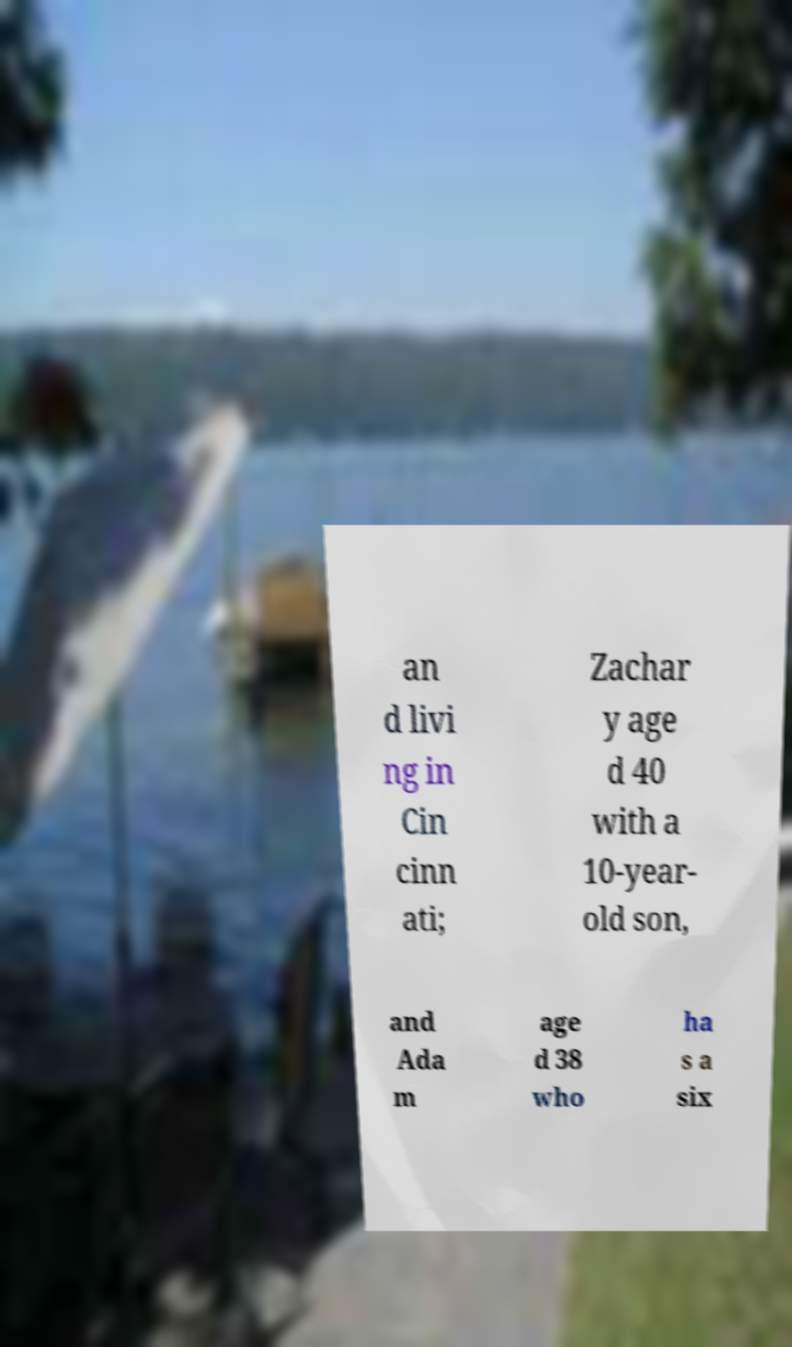There's text embedded in this image that I need extracted. Can you transcribe it verbatim? an d livi ng in Cin cinn ati; Zachar y age d 40 with a 10-year- old son, and Ada m age d 38 who ha s a six 